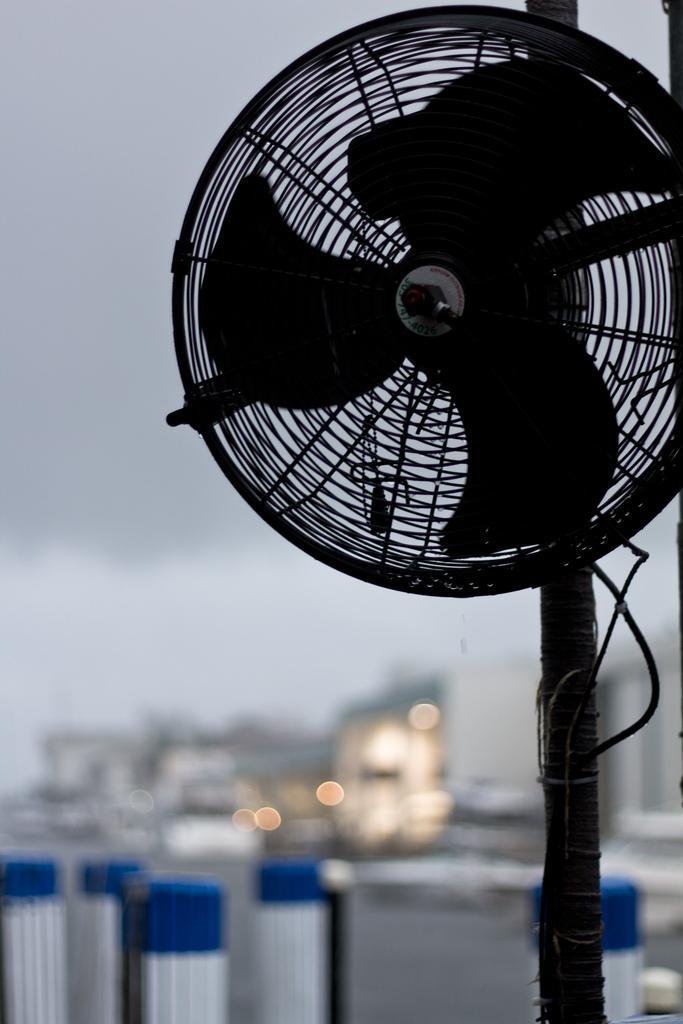Can you describe this image briefly? This image consists of a fan. In the background, there are buildings. At the top, there is sky. 